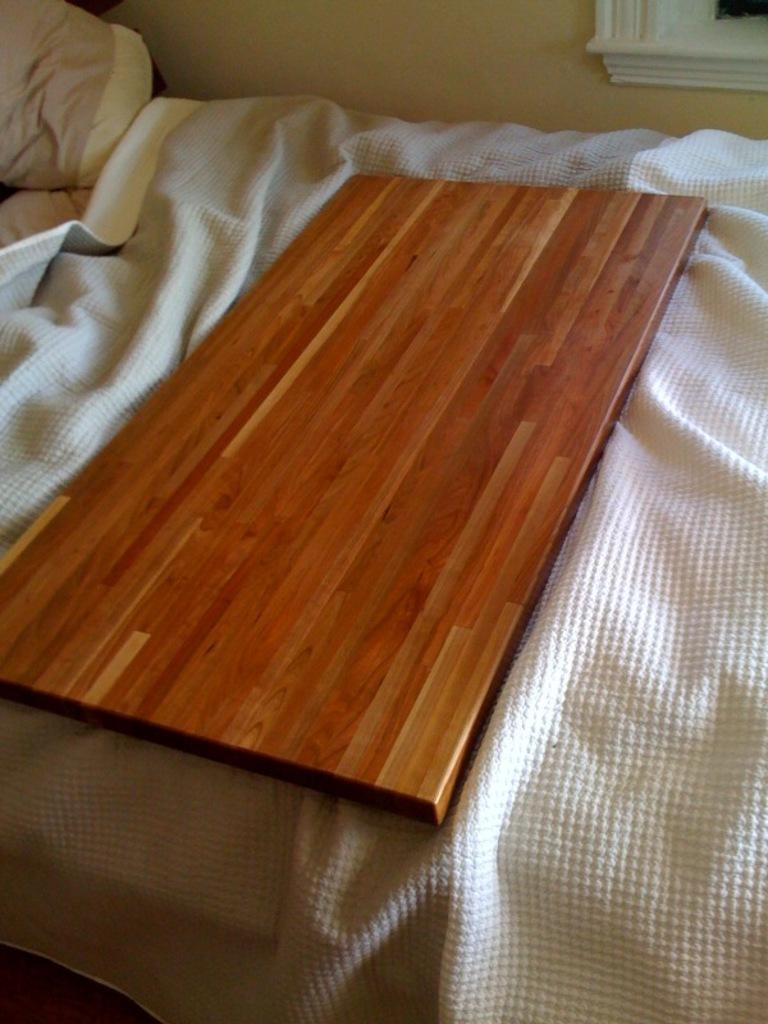In one or two sentences, can you explain what this image depicts? In this picture we can observe a wooden plank placed on the bed. There is a white color bed sheet on the bed. In the background we can observe a wall. 